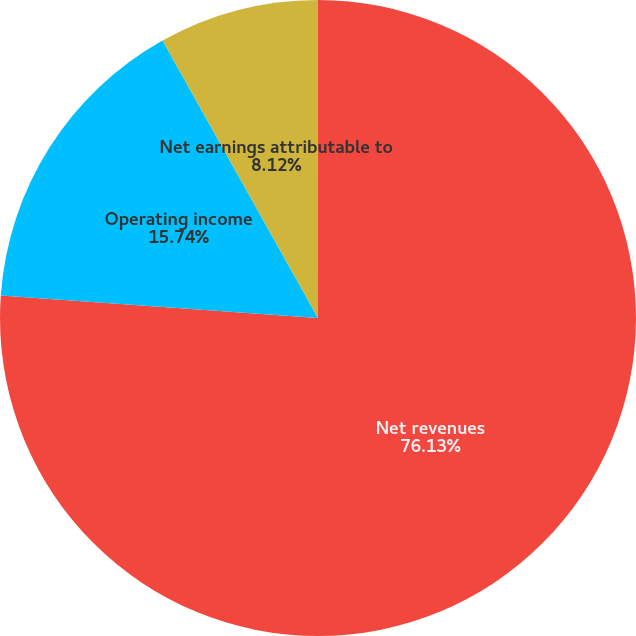<chart> <loc_0><loc_0><loc_500><loc_500><pie_chart><fcel>Net revenues<fcel>Operating income<fcel>Net earnings attributable to<fcel>EPS - diluted<nl><fcel>76.13%<fcel>15.74%<fcel>8.12%<fcel>0.01%<nl></chart> 